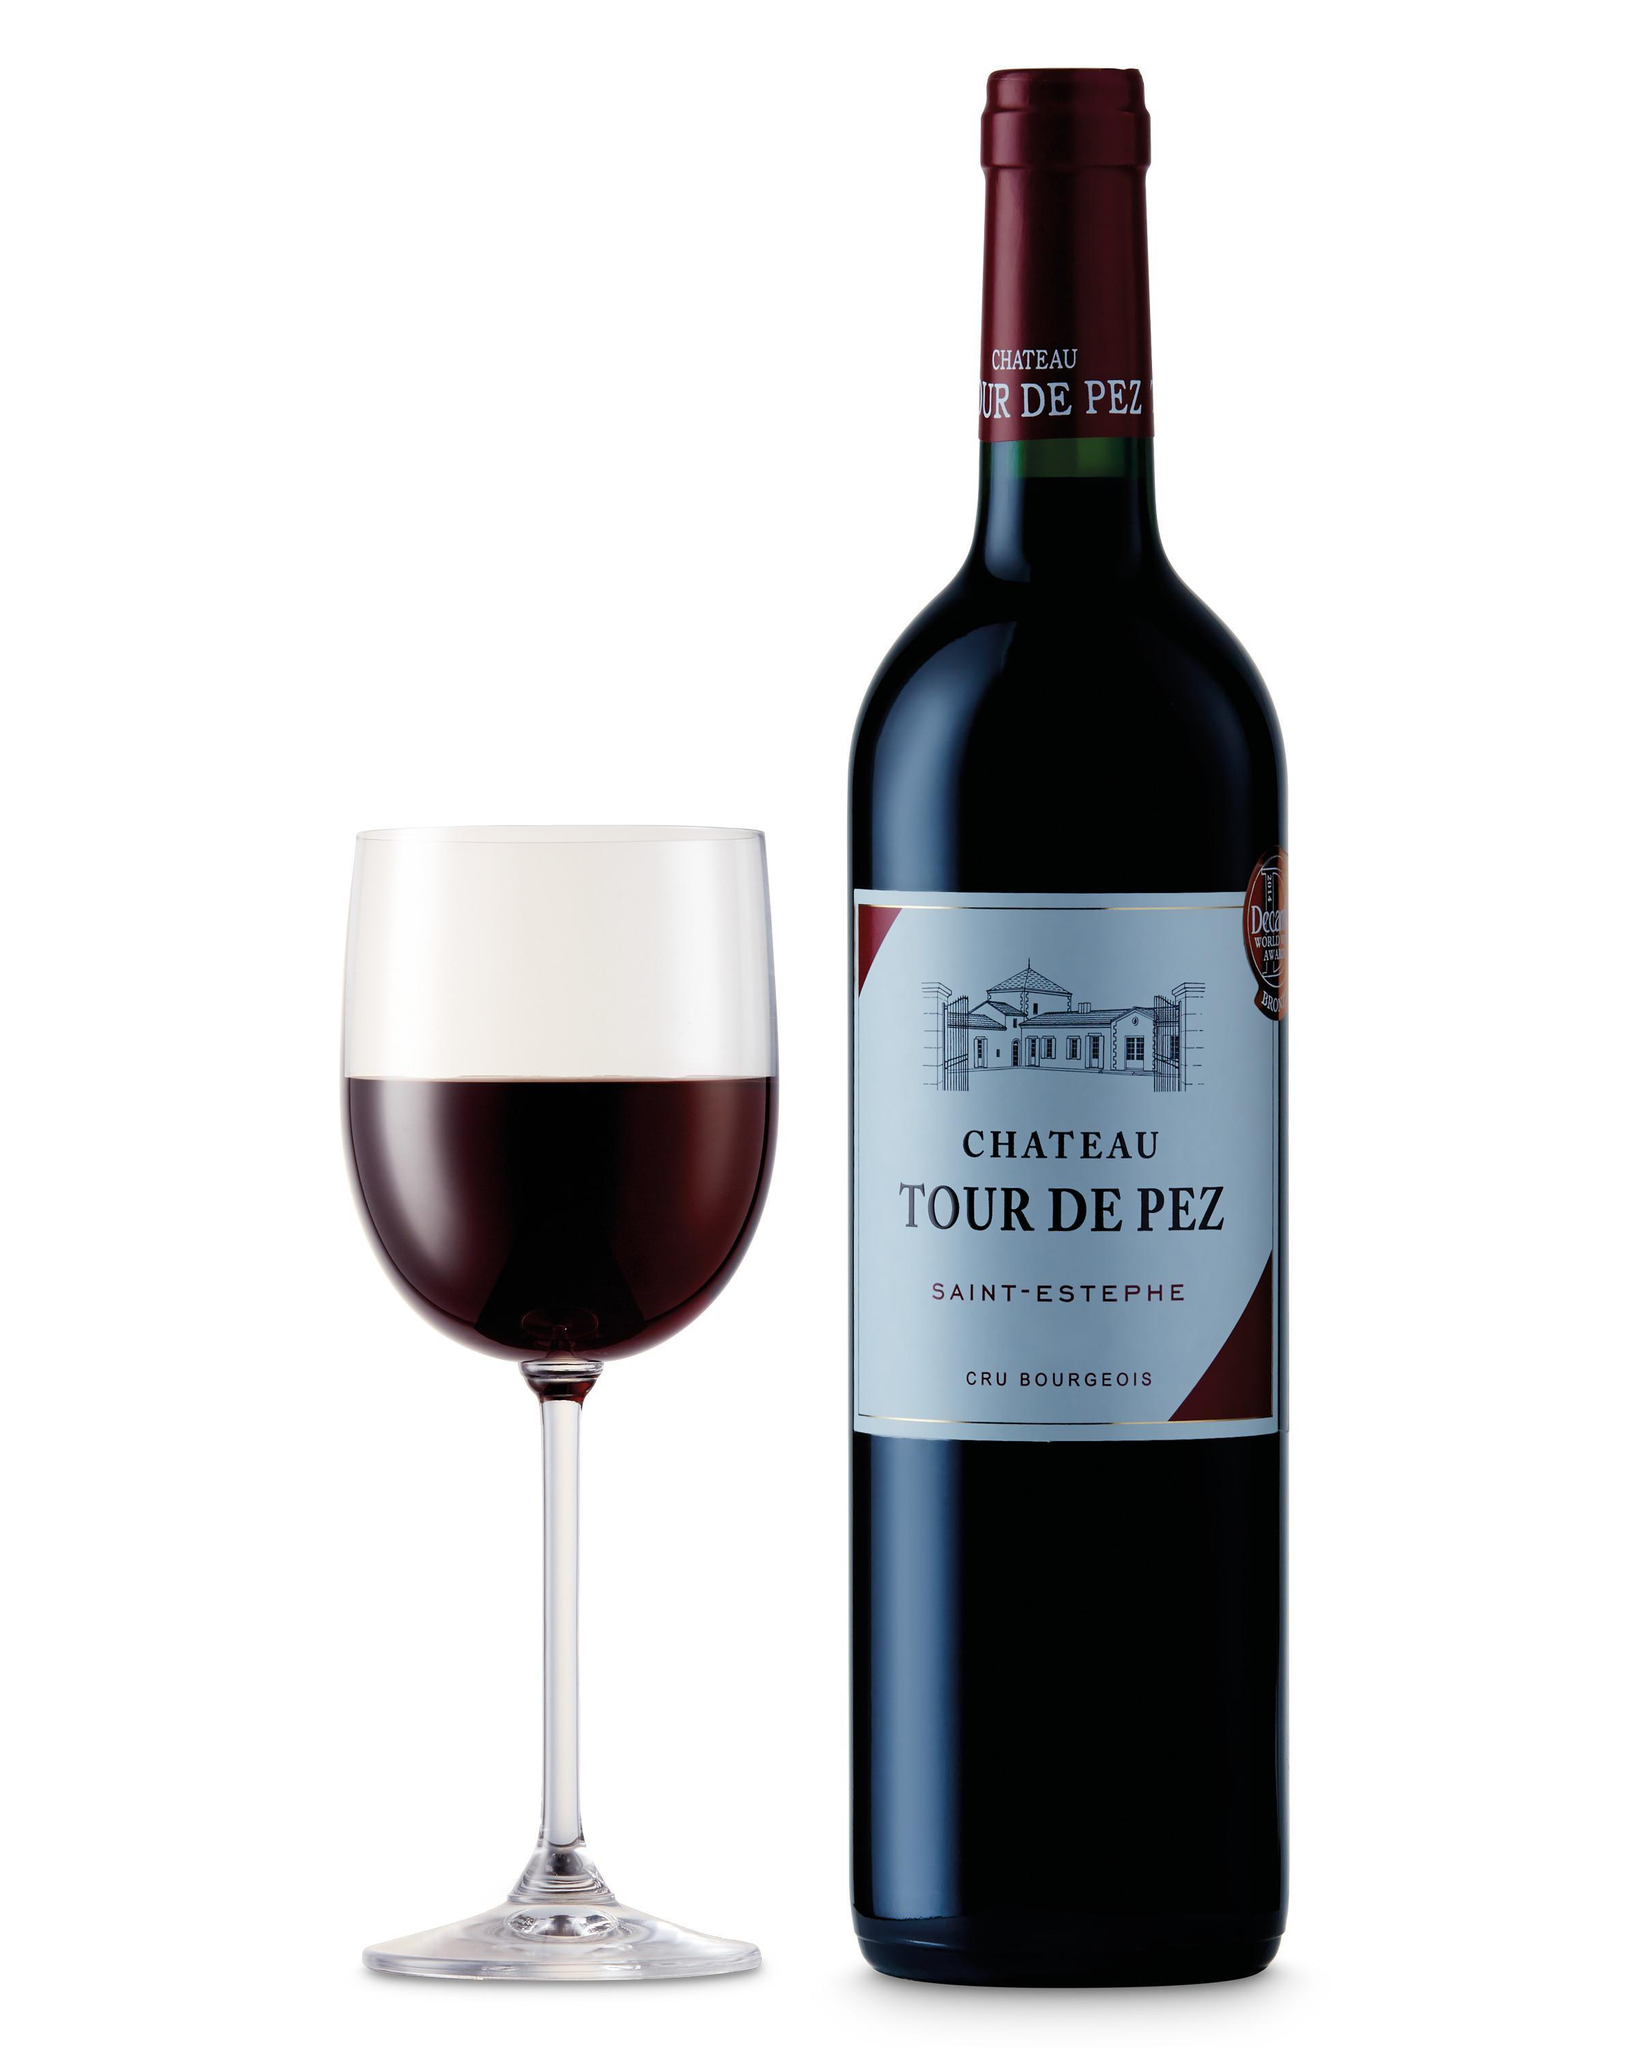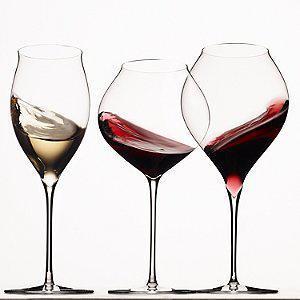The first image is the image on the left, the second image is the image on the right. Evaluate the accuracy of this statement regarding the images: "One of the images has exactly three partially filled glasses.". Is it true? Answer yes or no. Yes. The first image is the image on the left, the second image is the image on the right. Evaluate the accuracy of this statement regarding the images: "the image on the left has a wine glass next to the bottle". Is it true? Answer yes or no. Yes. 